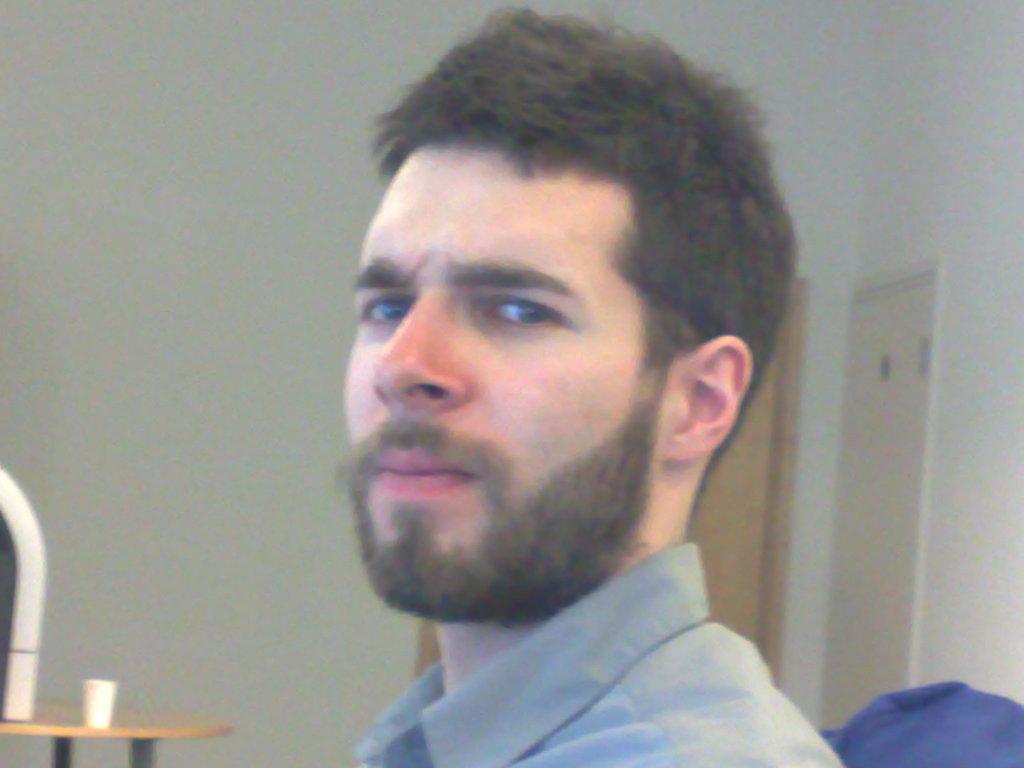Please provide a concise description of this image. This is the picture of a room. In this image there is a man sitting on the chair. At the back there are doors. On the left side of the image there is a glass and there is an object on the table. 